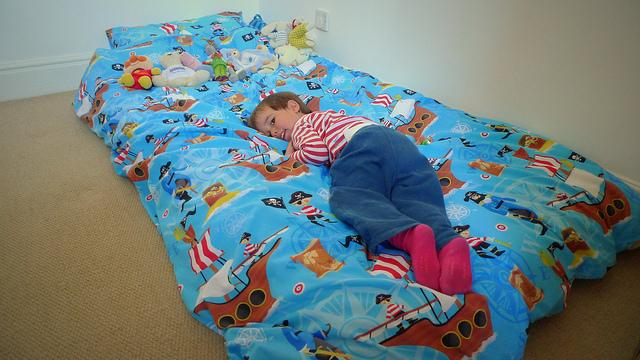The boy is wearing a shirt that looks like the shirt of a character in what series? waldo 